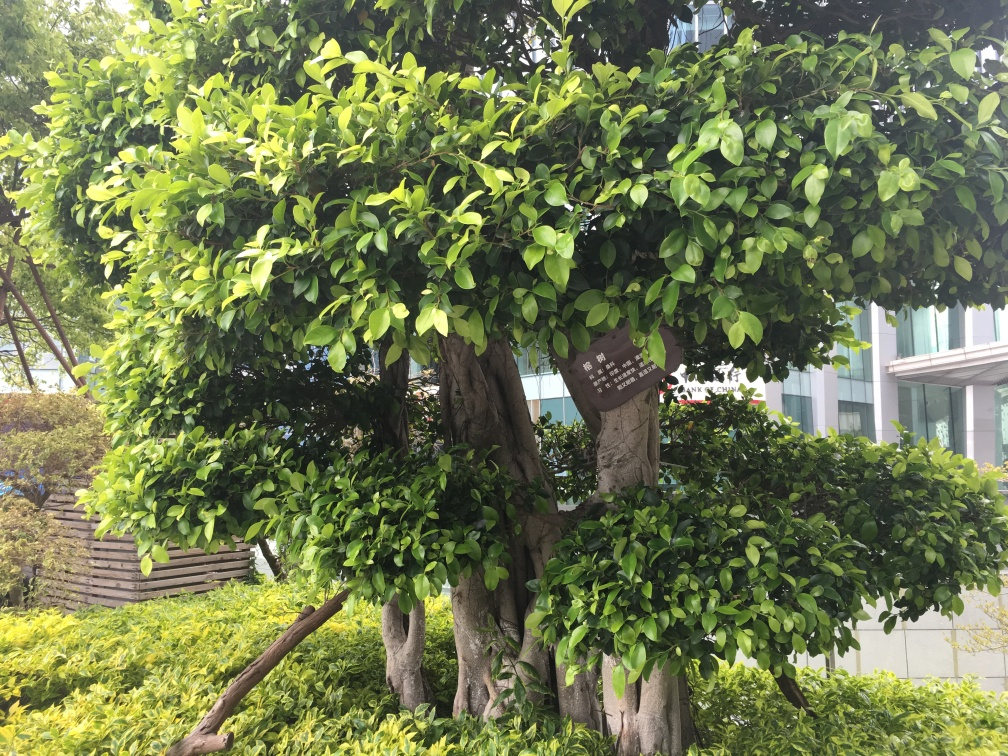What makes the contours and texture in this image quality clear and obvious?
A. Low definition and blurriness
B. High definition and clarity
C. Medium definition and clarity
Answer with the option's letter from the given choices directly.
 B. 